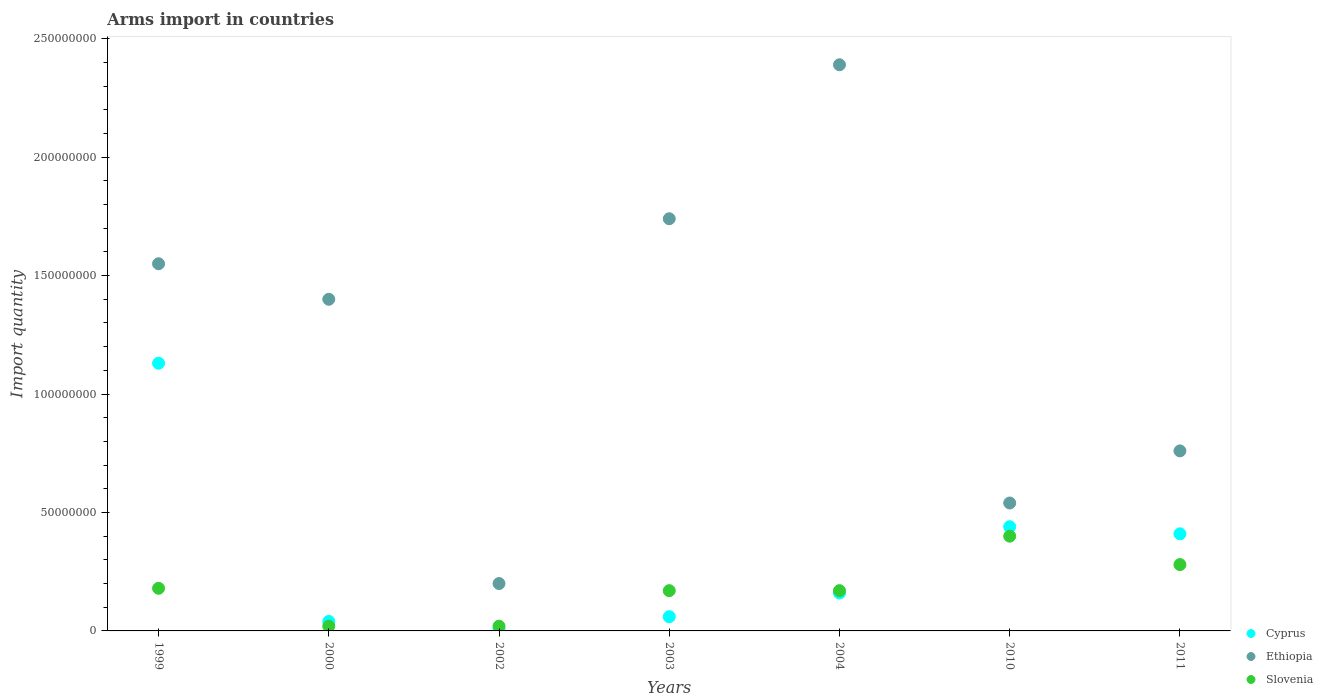What is the total arms import in Ethiopia in 2000?
Your answer should be compact. 1.40e+08. Across all years, what is the maximum total arms import in Cyprus?
Keep it short and to the point. 1.13e+08. Across all years, what is the minimum total arms import in Ethiopia?
Offer a terse response. 2.00e+07. What is the total total arms import in Slovenia in the graph?
Ensure brevity in your answer.  1.24e+08. What is the difference between the total arms import in Slovenia in 1999 and that in 2010?
Offer a terse response. -2.20e+07. What is the difference between the total arms import in Cyprus in 2003 and the total arms import in Slovenia in 1999?
Your response must be concise. -1.20e+07. What is the average total arms import in Ethiopia per year?
Ensure brevity in your answer.  1.23e+08. In how many years, is the total arms import in Cyprus greater than 110000000?
Keep it short and to the point. 1. What is the ratio of the total arms import in Ethiopia in 1999 to that in 2002?
Ensure brevity in your answer.  7.75. Is the difference between the total arms import in Slovenia in 1999 and 2004 greater than the difference between the total arms import in Cyprus in 1999 and 2004?
Make the answer very short. No. What is the difference between the highest and the second highest total arms import in Ethiopia?
Keep it short and to the point. 6.50e+07. What is the difference between the highest and the lowest total arms import in Cyprus?
Keep it short and to the point. 1.12e+08. In how many years, is the total arms import in Slovenia greater than the average total arms import in Slovenia taken over all years?
Give a very brief answer. 3. Is the sum of the total arms import in Ethiopia in 2002 and 2004 greater than the maximum total arms import in Slovenia across all years?
Your response must be concise. Yes. Is it the case that in every year, the sum of the total arms import in Slovenia and total arms import in Cyprus  is greater than the total arms import in Ethiopia?
Make the answer very short. No. Does the total arms import in Slovenia monotonically increase over the years?
Make the answer very short. No. Is the total arms import in Ethiopia strictly greater than the total arms import in Cyprus over the years?
Provide a succinct answer. Yes. How many years are there in the graph?
Your response must be concise. 7. Are the values on the major ticks of Y-axis written in scientific E-notation?
Give a very brief answer. No. Does the graph contain any zero values?
Provide a short and direct response. No. Where does the legend appear in the graph?
Your answer should be compact. Bottom right. What is the title of the graph?
Your answer should be very brief. Arms import in countries. What is the label or title of the Y-axis?
Keep it short and to the point. Import quantity. What is the Import quantity in Cyprus in 1999?
Make the answer very short. 1.13e+08. What is the Import quantity of Ethiopia in 1999?
Provide a short and direct response. 1.55e+08. What is the Import quantity of Slovenia in 1999?
Your answer should be compact. 1.80e+07. What is the Import quantity in Cyprus in 2000?
Give a very brief answer. 4.00e+06. What is the Import quantity of Ethiopia in 2000?
Provide a succinct answer. 1.40e+08. What is the Import quantity in Slovenia in 2000?
Give a very brief answer. 2.00e+06. What is the Import quantity of Cyprus in 2002?
Offer a very short reply. 1.00e+06. What is the Import quantity in Ethiopia in 2002?
Give a very brief answer. 2.00e+07. What is the Import quantity in Slovenia in 2002?
Give a very brief answer. 2.00e+06. What is the Import quantity of Ethiopia in 2003?
Provide a succinct answer. 1.74e+08. What is the Import quantity in Slovenia in 2003?
Ensure brevity in your answer.  1.70e+07. What is the Import quantity in Cyprus in 2004?
Your answer should be very brief. 1.60e+07. What is the Import quantity in Ethiopia in 2004?
Your answer should be compact. 2.39e+08. What is the Import quantity in Slovenia in 2004?
Your answer should be very brief. 1.70e+07. What is the Import quantity in Cyprus in 2010?
Offer a terse response. 4.40e+07. What is the Import quantity in Ethiopia in 2010?
Provide a succinct answer. 5.40e+07. What is the Import quantity in Slovenia in 2010?
Offer a very short reply. 4.00e+07. What is the Import quantity of Cyprus in 2011?
Offer a terse response. 4.10e+07. What is the Import quantity in Ethiopia in 2011?
Your response must be concise. 7.60e+07. What is the Import quantity of Slovenia in 2011?
Provide a short and direct response. 2.80e+07. Across all years, what is the maximum Import quantity of Cyprus?
Give a very brief answer. 1.13e+08. Across all years, what is the maximum Import quantity in Ethiopia?
Make the answer very short. 2.39e+08. Across all years, what is the maximum Import quantity in Slovenia?
Your answer should be very brief. 4.00e+07. Across all years, what is the minimum Import quantity of Cyprus?
Ensure brevity in your answer.  1.00e+06. Across all years, what is the minimum Import quantity of Ethiopia?
Keep it short and to the point. 2.00e+07. What is the total Import quantity of Cyprus in the graph?
Ensure brevity in your answer.  2.25e+08. What is the total Import quantity in Ethiopia in the graph?
Offer a very short reply. 8.58e+08. What is the total Import quantity in Slovenia in the graph?
Give a very brief answer. 1.24e+08. What is the difference between the Import quantity of Cyprus in 1999 and that in 2000?
Your answer should be very brief. 1.09e+08. What is the difference between the Import quantity in Ethiopia in 1999 and that in 2000?
Your answer should be compact. 1.50e+07. What is the difference between the Import quantity of Slovenia in 1999 and that in 2000?
Make the answer very short. 1.60e+07. What is the difference between the Import quantity in Cyprus in 1999 and that in 2002?
Your answer should be compact. 1.12e+08. What is the difference between the Import quantity in Ethiopia in 1999 and that in 2002?
Offer a very short reply. 1.35e+08. What is the difference between the Import quantity in Slovenia in 1999 and that in 2002?
Provide a short and direct response. 1.60e+07. What is the difference between the Import quantity of Cyprus in 1999 and that in 2003?
Provide a short and direct response. 1.07e+08. What is the difference between the Import quantity of Ethiopia in 1999 and that in 2003?
Make the answer very short. -1.90e+07. What is the difference between the Import quantity in Slovenia in 1999 and that in 2003?
Provide a short and direct response. 1.00e+06. What is the difference between the Import quantity in Cyprus in 1999 and that in 2004?
Keep it short and to the point. 9.70e+07. What is the difference between the Import quantity in Ethiopia in 1999 and that in 2004?
Offer a very short reply. -8.40e+07. What is the difference between the Import quantity of Slovenia in 1999 and that in 2004?
Provide a succinct answer. 1.00e+06. What is the difference between the Import quantity in Cyprus in 1999 and that in 2010?
Keep it short and to the point. 6.90e+07. What is the difference between the Import quantity in Ethiopia in 1999 and that in 2010?
Provide a succinct answer. 1.01e+08. What is the difference between the Import quantity of Slovenia in 1999 and that in 2010?
Your answer should be compact. -2.20e+07. What is the difference between the Import quantity in Cyprus in 1999 and that in 2011?
Provide a short and direct response. 7.20e+07. What is the difference between the Import quantity in Ethiopia in 1999 and that in 2011?
Provide a succinct answer. 7.90e+07. What is the difference between the Import quantity of Slovenia in 1999 and that in 2011?
Provide a short and direct response. -1.00e+07. What is the difference between the Import quantity of Cyprus in 2000 and that in 2002?
Make the answer very short. 3.00e+06. What is the difference between the Import quantity of Ethiopia in 2000 and that in 2002?
Offer a terse response. 1.20e+08. What is the difference between the Import quantity in Slovenia in 2000 and that in 2002?
Make the answer very short. 0. What is the difference between the Import quantity in Ethiopia in 2000 and that in 2003?
Provide a short and direct response. -3.40e+07. What is the difference between the Import quantity in Slovenia in 2000 and that in 2003?
Offer a terse response. -1.50e+07. What is the difference between the Import quantity in Cyprus in 2000 and that in 2004?
Provide a succinct answer. -1.20e+07. What is the difference between the Import quantity in Ethiopia in 2000 and that in 2004?
Provide a succinct answer. -9.90e+07. What is the difference between the Import quantity in Slovenia in 2000 and that in 2004?
Keep it short and to the point. -1.50e+07. What is the difference between the Import quantity of Cyprus in 2000 and that in 2010?
Your answer should be very brief. -4.00e+07. What is the difference between the Import quantity of Ethiopia in 2000 and that in 2010?
Offer a very short reply. 8.60e+07. What is the difference between the Import quantity in Slovenia in 2000 and that in 2010?
Give a very brief answer. -3.80e+07. What is the difference between the Import quantity in Cyprus in 2000 and that in 2011?
Ensure brevity in your answer.  -3.70e+07. What is the difference between the Import quantity in Ethiopia in 2000 and that in 2011?
Your answer should be very brief. 6.40e+07. What is the difference between the Import quantity of Slovenia in 2000 and that in 2011?
Ensure brevity in your answer.  -2.60e+07. What is the difference between the Import quantity of Cyprus in 2002 and that in 2003?
Offer a very short reply. -5.00e+06. What is the difference between the Import quantity in Ethiopia in 2002 and that in 2003?
Ensure brevity in your answer.  -1.54e+08. What is the difference between the Import quantity of Slovenia in 2002 and that in 2003?
Provide a short and direct response. -1.50e+07. What is the difference between the Import quantity in Cyprus in 2002 and that in 2004?
Give a very brief answer. -1.50e+07. What is the difference between the Import quantity in Ethiopia in 2002 and that in 2004?
Give a very brief answer. -2.19e+08. What is the difference between the Import quantity in Slovenia in 2002 and that in 2004?
Your response must be concise. -1.50e+07. What is the difference between the Import quantity in Cyprus in 2002 and that in 2010?
Give a very brief answer. -4.30e+07. What is the difference between the Import quantity of Ethiopia in 2002 and that in 2010?
Provide a succinct answer. -3.40e+07. What is the difference between the Import quantity of Slovenia in 2002 and that in 2010?
Make the answer very short. -3.80e+07. What is the difference between the Import quantity in Cyprus in 2002 and that in 2011?
Ensure brevity in your answer.  -4.00e+07. What is the difference between the Import quantity in Ethiopia in 2002 and that in 2011?
Your response must be concise. -5.60e+07. What is the difference between the Import quantity in Slovenia in 2002 and that in 2011?
Your answer should be very brief. -2.60e+07. What is the difference between the Import quantity in Cyprus in 2003 and that in 2004?
Keep it short and to the point. -1.00e+07. What is the difference between the Import quantity in Ethiopia in 2003 and that in 2004?
Keep it short and to the point. -6.50e+07. What is the difference between the Import quantity of Slovenia in 2003 and that in 2004?
Ensure brevity in your answer.  0. What is the difference between the Import quantity of Cyprus in 2003 and that in 2010?
Offer a terse response. -3.80e+07. What is the difference between the Import quantity in Ethiopia in 2003 and that in 2010?
Offer a terse response. 1.20e+08. What is the difference between the Import quantity of Slovenia in 2003 and that in 2010?
Your answer should be very brief. -2.30e+07. What is the difference between the Import quantity of Cyprus in 2003 and that in 2011?
Provide a succinct answer. -3.50e+07. What is the difference between the Import quantity of Ethiopia in 2003 and that in 2011?
Offer a very short reply. 9.80e+07. What is the difference between the Import quantity of Slovenia in 2003 and that in 2011?
Provide a short and direct response. -1.10e+07. What is the difference between the Import quantity of Cyprus in 2004 and that in 2010?
Provide a succinct answer. -2.80e+07. What is the difference between the Import quantity of Ethiopia in 2004 and that in 2010?
Offer a terse response. 1.85e+08. What is the difference between the Import quantity of Slovenia in 2004 and that in 2010?
Offer a terse response. -2.30e+07. What is the difference between the Import quantity in Cyprus in 2004 and that in 2011?
Offer a terse response. -2.50e+07. What is the difference between the Import quantity of Ethiopia in 2004 and that in 2011?
Give a very brief answer. 1.63e+08. What is the difference between the Import quantity of Slovenia in 2004 and that in 2011?
Offer a terse response. -1.10e+07. What is the difference between the Import quantity in Cyprus in 2010 and that in 2011?
Provide a succinct answer. 3.00e+06. What is the difference between the Import quantity of Ethiopia in 2010 and that in 2011?
Provide a succinct answer. -2.20e+07. What is the difference between the Import quantity of Slovenia in 2010 and that in 2011?
Your answer should be very brief. 1.20e+07. What is the difference between the Import quantity of Cyprus in 1999 and the Import quantity of Ethiopia in 2000?
Ensure brevity in your answer.  -2.70e+07. What is the difference between the Import quantity of Cyprus in 1999 and the Import quantity of Slovenia in 2000?
Provide a short and direct response. 1.11e+08. What is the difference between the Import quantity in Ethiopia in 1999 and the Import quantity in Slovenia in 2000?
Make the answer very short. 1.53e+08. What is the difference between the Import quantity of Cyprus in 1999 and the Import quantity of Ethiopia in 2002?
Provide a succinct answer. 9.30e+07. What is the difference between the Import quantity of Cyprus in 1999 and the Import quantity of Slovenia in 2002?
Your answer should be very brief. 1.11e+08. What is the difference between the Import quantity in Ethiopia in 1999 and the Import quantity in Slovenia in 2002?
Give a very brief answer. 1.53e+08. What is the difference between the Import quantity in Cyprus in 1999 and the Import quantity in Ethiopia in 2003?
Provide a succinct answer. -6.10e+07. What is the difference between the Import quantity in Cyprus in 1999 and the Import quantity in Slovenia in 2003?
Ensure brevity in your answer.  9.60e+07. What is the difference between the Import quantity of Ethiopia in 1999 and the Import quantity of Slovenia in 2003?
Make the answer very short. 1.38e+08. What is the difference between the Import quantity of Cyprus in 1999 and the Import quantity of Ethiopia in 2004?
Your answer should be very brief. -1.26e+08. What is the difference between the Import quantity in Cyprus in 1999 and the Import quantity in Slovenia in 2004?
Your answer should be very brief. 9.60e+07. What is the difference between the Import quantity of Ethiopia in 1999 and the Import quantity of Slovenia in 2004?
Offer a very short reply. 1.38e+08. What is the difference between the Import quantity in Cyprus in 1999 and the Import quantity in Ethiopia in 2010?
Offer a very short reply. 5.90e+07. What is the difference between the Import quantity of Cyprus in 1999 and the Import quantity of Slovenia in 2010?
Make the answer very short. 7.30e+07. What is the difference between the Import quantity of Ethiopia in 1999 and the Import quantity of Slovenia in 2010?
Ensure brevity in your answer.  1.15e+08. What is the difference between the Import quantity in Cyprus in 1999 and the Import quantity in Ethiopia in 2011?
Provide a succinct answer. 3.70e+07. What is the difference between the Import quantity in Cyprus in 1999 and the Import quantity in Slovenia in 2011?
Ensure brevity in your answer.  8.50e+07. What is the difference between the Import quantity in Ethiopia in 1999 and the Import quantity in Slovenia in 2011?
Your answer should be very brief. 1.27e+08. What is the difference between the Import quantity in Cyprus in 2000 and the Import quantity in Ethiopia in 2002?
Make the answer very short. -1.60e+07. What is the difference between the Import quantity of Cyprus in 2000 and the Import quantity of Slovenia in 2002?
Make the answer very short. 2.00e+06. What is the difference between the Import quantity in Ethiopia in 2000 and the Import quantity in Slovenia in 2002?
Make the answer very short. 1.38e+08. What is the difference between the Import quantity in Cyprus in 2000 and the Import quantity in Ethiopia in 2003?
Offer a terse response. -1.70e+08. What is the difference between the Import quantity of Cyprus in 2000 and the Import quantity of Slovenia in 2003?
Provide a short and direct response. -1.30e+07. What is the difference between the Import quantity in Ethiopia in 2000 and the Import quantity in Slovenia in 2003?
Ensure brevity in your answer.  1.23e+08. What is the difference between the Import quantity in Cyprus in 2000 and the Import quantity in Ethiopia in 2004?
Keep it short and to the point. -2.35e+08. What is the difference between the Import quantity in Cyprus in 2000 and the Import quantity in Slovenia in 2004?
Offer a terse response. -1.30e+07. What is the difference between the Import quantity in Ethiopia in 2000 and the Import quantity in Slovenia in 2004?
Provide a succinct answer. 1.23e+08. What is the difference between the Import quantity in Cyprus in 2000 and the Import quantity in Ethiopia in 2010?
Make the answer very short. -5.00e+07. What is the difference between the Import quantity in Cyprus in 2000 and the Import quantity in Slovenia in 2010?
Ensure brevity in your answer.  -3.60e+07. What is the difference between the Import quantity in Cyprus in 2000 and the Import quantity in Ethiopia in 2011?
Your answer should be very brief. -7.20e+07. What is the difference between the Import quantity in Cyprus in 2000 and the Import quantity in Slovenia in 2011?
Ensure brevity in your answer.  -2.40e+07. What is the difference between the Import quantity in Ethiopia in 2000 and the Import quantity in Slovenia in 2011?
Your answer should be very brief. 1.12e+08. What is the difference between the Import quantity in Cyprus in 2002 and the Import quantity in Ethiopia in 2003?
Your answer should be very brief. -1.73e+08. What is the difference between the Import quantity of Cyprus in 2002 and the Import quantity of Slovenia in 2003?
Provide a succinct answer. -1.60e+07. What is the difference between the Import quantity in Cyprus in 2002 and the Import quantity in Ethiopia in 2004?
Your answer should be compact. -2.38e+08. What is the difference between the Import quantity in Cyprus in 2002 and the Import quantity in Slovenia in 2004?
Provide a succinct answer. -1.60e+07. What is the difference between the Import quantity in Ethiopia in 2002 and the Import quantity in Slovenia in 2004?
Ensure brevity in your answer.  3.00e+06. What is the difference between the Import quantity of Cyprus in 2002 and the Import quantity of Ethiopia in 2010?
Your answer should be compact. -5.30e+07. What is the difference between the Import quantity in Cyprus in 2002 and the Import quantity in Slovenia in 2010?
Provide a succinct answer. -3.90e+07. What is the difference between the Import quantity of Ethiopia in 2002 and the Import quantity of Slovenia in 2010?
Give a very brief answer. -2.00e+07. What is the difference between the Import quantity of Cyprus in 2002 and the Import quantity of Ethiopia in 2011?
Ensure brevity in your answer.  -7.50e+07. What is the difference between the Import quantity of Cyprus in 2002 and the Import quantity of Slovenia in 2011?
Your response must be concise. -2.70e+07. What is the difference between the Import quantity in Ethiopia in 2002 and the Import quantity in Slovenia in 2011?
Offer a terse response. -8.00e+06. What is the difference between the Import quantity in Cyprus in 2003 and the Import quantity in Ethiopia in 2004?
Your answer should be compact. -2.33e+08. What is the difference between the Import quantity in Cyprus in 2003 and the Import quantity in Slovenia in 2004?
Your answer should be very brief. -1.10e+07. What is the difference between the Import quantity in Ethiopia in 2003 and the Import quantity in Slovenia in 2004?
Provide a short and direct response. 1.57e+08. What is the difference between the Import quantity of Cyprus in 2003 and the Import quantity of Ethiopia in 2010?
Offer a terse response. -4.80e+07. What is the difference between the Import quantity of Cyprus in 2003 and the Import quantity of Slovenia in 2010?
Offer a terse response. -3.40e+07. What is the difference between the Import quantity of Ethiopia in 2003 and the Import quantity of Slovenia in 2010?
Give a very brief answer. 1.34e+08. What is the difference between the Import quantity of Cyprus in 2003 and the Import quantity of Ethiopia in 2011?
Give a very brief answer. -7.00e+07. What is the difference between the Import quantity in Cyprus in 2003 and the Import quantity in Slovenia in 2011?
Your response must be concise. -2.20e+07. What is the difference between the Import quantity of Ethiopia in 2003 and the Import quantity of Slovenia in 2011?
Ensure brevity in your answer.  1.46e+08. What is the difference between the Import quantity in Cyprus in 2004 and the Import quantity in Ethiopia in 2010?
Keep it short and to the point. -3.80e+07. What is the difference between the Import quantity in Cyprus in 2004 and the Import quantity in Slovenia in 2010?
Ensure brevity in your answer.  -2.40e+07. What is the difference between the Import quantity of Ethiopia in 2004 and the Import quantity of Slovenia in 2010?
Provide a succinct answer. 1.99e+08. What is the difference between the Import quantity of Cyprus in 2004 and the Import quantity of Ethiopia in 2011?
Offer a terse response. -6.00e+07. What is the difference between the Import quantity in Cyprus in 2004 and the Import quantity in Slovenia in 2011?
Your response must be concise. -1.20e+07. What is the difference between the Import quantity of Ethiopia in 2004 and the Import quantity of Slovenia in 2011?
Provide a short and direct response. 2.11e+08. What is the difference between the Import quantity in Cyprus in 2010 and the Import quantity in Ethiopia in 2011?
Keep it short and to the point. -3.20e+07. What is the difference between the Import quantity of Cyprus in 2010 and the Import quantity of Slovenia in 2011?
Offer a terse response. 1.60e+07. What is the difference between the Import quantity of Ethiopia in 2010 and the Import quantity of Slovenia in 2011?
Keep it short and to the point. 2.60e+07. What is the average Import quantity of Cyprus per year?
Keep it short and to the point. 3.21e+07. What is the average Import quantity of Ethiopia per year?
Give a very brief answer. 1.23e+08. What is the average Import quantity in Slovenia per year?
Provide a short and direct response. 1.77e+07. In the year 1999, what is the difference between the Import quantity in Cyprus and Import quantity in Ethiopia?
Make the answer very short. -4.20e+07. In the year 1999, what is the difference between the Import quantity in Cyprus and Import quantity in Slovenia?
Keep it short and to the point. 9.50e+07. In the year 1999, what is the difference between the Import quantity in Ethiopia and Import quantity in Slovenia?
Provide a succinct answer. 1.37e+08. In the year 2000, what is the difference between the Import quantity in Cyprus and Import quantity in Ethiopia?
Your answer should be compact. -1.36e+08. In the year 2000, what is the difference between the Import quantity of Cyprus and Import quantity of Slovenia?
Your answer should be compact. 2.00e+06. In the year 2000, what is the difference between the Import quantity of Ethiopia and Import quantity of Slovenia?
Make the answer very short. 1.38e+08. In the year 2002, what is the difference between the Import quantity in Cyprus and Import quantity in Ethiopia?
Offer a very short reply. -1.90e+07. In the year 2002, what is the difference between the Import quantity in Ethiopia and Import quantity in Slovenia?
Provide a short and direct response. 1.80e+07. In the year 2003, what is the difference between the Import quantity of Cyprus and Import quantity of Ethiopia?
Your answer should be very brief. -1.68e+08. In the year 2003, what is the difference between the Import quantity of Cyprus and Import quantity of Slovenia?
Offer a terse response. -1.10e+07. In the year 2003, what is the difference between the Import quantity of Ethiopia and Import quantity of Slovenia?
Provide a succinct answer. 1.57e+08. In the year 2004, what is the difference between the Import quantity in Cyprus and Import quantity in Ethiopia?
Your answer should be very brief. -2.23e+08. In the year 2004, what is the difference between the Import quantity in Ethiopia and Import quantity in Slovenia?
Provide a short and direct response. 2.22e+08. In the year 2010, what is the difference between the Import quantity in Cyprus and Import quantity in Ethiopia?
Your response must be concise. -1.00e+07. In the year 2010, what is the difference between the Import quantity of Ethiopia and Import quantity of Slovenia?
Keep it short and to the point. 1.40e+07. In the year 2011, what is the difference between the Import quantity in Cyprus and Import quantity in Ethiopia?
Provide a short and direct response. -3.50e+07. In the year 2011, what is the difference between the Import quantity of Cyprus and Import quantity of Slovenia?
Your response must be concise. 1.30e+07. In the year 2011, what is the difference between the Import quantity of Ethiopia and Import quantity of Slovenia?
Your answer should be very brief. 4.80e+07. What is the ratio of the Import quantity of Cyprus in 1999 to that in 2000?
Your answer should be very brief. 28.25. What is the ratio of the Import quantity of Ethiopia in 1999 to that in 2000?
Give a very brief answer. 1.11. What is the ratio of the Import quantity in Slovenia in 1999 to that in 2000?
Ensure brevity in your answer.  9. What is the ratio of the Import quantity in Cyprus in 1999 to that in 2002?
Keep it short and to the point. 113. What is the ratio of the Import quantity in Ethiopia in 1999 to that in 2002?
Provide a short and direct response. 7.75. What is the ratio of the Import quantity in Slovenia in 1999 to that in 2002?
Offer a very short reply. 9. What is the ratio of the Import quantity of Cyprus in 1999 to that in 2003?
Keep it short and to the point. 18.83. What is the ratio of the Import quantity in Ethiopia in 1999 to that in 2003?
Make the answer very short. 0.89. What is the ratio of the Import quantity in Slovenia in 1999 to that in 2003?
Offer a terse response. 1.06. What is the ratio of the Import quantity of Cyprus in 1999 to that in 2004?
Provide a succinct answer. 7.06. What is the ratio of the Import quantity of Ethiopia in 1999 to that in 2004?
Keep it short and to the point. 0.65. What is the ratio of the Import quantity of Slovenia in 1999 to that in 2004?
Offer a very short reply. 1.06. What is the ratio of the Import quantity of Cyprus in 1999 to that in 2010?
Your response must be concise. 2.57. What is the ratio of the Import quantity of Ethiopia in 1999 to that in 2010?
Ensure brevity in your answer.  2.87. What is the ratio of the Import quantity in Slovenia in 1999 to that in 2010?
Ensure brevity in your answer.  0.45. What is the ratio of the Import quantity of Cyprus in 1999 to that in 2011?
Ensure brevity in your answer.  2.76. What is the ratio of the Import quantity of Ethiopia in 1999 to that in 2011?
Provide a short and direct response. 2.04. What is the ratio of the Import quantity of Slovenia in 1999 to that in 2011?
Provide a short and direct response. 0.64. What is the ratio of the Import quantity of Ethiopia in 2000 to that in 2003?
Give a very brief answer. 0.8. What is the ratio of the Import quantity of Slovenia in 2000 to that in 2003?
Offer a terse response. 0.12. What is the ratio of the Import quantity of Cyprus in 2000 to that in 2004?
Provide a short and direct response. 0.25. What is the ratio of the Import quantity in Ethiopia in 2000 to that in 2004?
Keep it short and to the point. 0.59. What is the ratio of the Import quantity in Slovenia in 2000 to that in 2004?
Give a very brief answer. 0.12. What is the ratio of the Import quantity of Cyprus in 2000 to that in 2010?
Make the answer very short. 0.09. What is the ratio of the Import quantity in Ethiopia in 2000 to that in 2010?
Your response must be concise. 2.59. What is the ratio of the Import quantity in Cyprus in 2000 to that in 2011?
Your response must be concise. 0.1. What is the ratio of the Import quantity in Ethiopia in 2000 to that in 2011?
Make the answer very short. 1.84. What is the ratio of the Import quantity of Slovenia in 2000 to that in 2011?
Make the answer very short. 0.07. What is the ratio of the Import quantity in Cyprus in 2002 to that in 2003?
Make the answer very short. 0.17. What is the ratio of the Import quantity in Ethiopia in 2002 to that in 2003?
Offer a terse response. 0.11. What is the ratio of the Import quantity of Slovenia in 2002 to that in 2003?
Make the answer very short. 0.12. What is the ratio of the Import quantity of Cyprus in 2002 to that in 2004?
Your answer should be compact. 0.06. What is the ratio of the Import quantity in Ethiopia in 2002 to that in 2004?
Your answer should be compact. 0.08. What is the ratio of the Import quantity in Slovenia in 2002 to that in 2004?
Provide a short and direct response. 0.12. What is the ratio of the Import quantity of Cyprus in 2002 to that in 2010?
Give a very brief answer. 0.02. What is the ratio of the Import quantity in Ethiopia in 2002 to that in 2010?
Your answer should be very brief. 0.37. What is the ratio of the Import quantity of Slovenia in 2002 to that in 2010?
Make the answer very short. 0.05. What is the ratio of the Import quantity of Cyprus in 2002 to that in 2011?
Provide a short and direct response. 0.02. What is the ratio of the Import quantity in Ethiopia in 2002 to that in 2011?
Your response must be concise. 0.26. What is the ratio of the Import quantity in Slovenia in 2002 to that in 2011?
Your response must be concise. 0.07. What is the ratio of the Import quantity of Ethiopia in 2003 to that in 2004?
Provide a short and direct response. 0.73. What is the ratio of the Import quantity in Cyprus in 2003 to that in 2010?
Ensure brevity in your answer.  0.14. What is the ratio of the Import quantity in Ethiopia in 2003 to that in 2010?
Offer a terse response. 3.22. What is the ratio of the Import quantity of Slovenia in 2003 to that in 2010?
Give a very brief answer. 0.42. What is the ratio of the Import quantity of Cyprus in 2003 to that in 2011?
Offer a very short reply. 0.15. What is the ratio of the Import quantity in Ethiopia in 2003 to that in 2011?
Your answer should be compact. 2.29. What is the ratio of the Import quantity in Slovenia in 2003 to that in 2011?
Provide a succinct answer. 0.61. What is the ratio of the Import quantity of Cyprus in 2004 to that in 2010?
Make the answer very short. 0.36. What is the ratio of the Import quantity in Ethiopia in 2004 to that in 2010?
Ensure brevity in your answer.  4.43. What is the ratio of the Import quantity in Slovenia in 2004 to that in 2010?
Your answer should be very brief. 0.42. What is the ratio of the Import quantity of Cyprus in 2004 to that in 2011?
Provide a short and direct response. 0.39. What is the ratio of the Import quantity in Ethiopia in 2004 to that in 2011?
Keep it short and to the point. 3.14. What is the ratio of the Import quantity of Slovenia in 2004 to that in 2011?
Offer a terse response. 0.61. What is the ratio of the Import quantity of Cyprus in 2010 to that in 2011?
Your response must be concise. 1.07. What is the ratio of the Import quantity of Ethiopia in 2010 to that in 2011?
Provide a succinct answer. 0.71. What is the ratio of the Import quantity in Slovenia in 2010 to that in 2011?
Keep it short and to the point. 1.43. What is the difference between the highest and the second highest Import quantity of Cyprus?
Provide a short and direct response. 6.90e+07. What is the difference between the highest and the second highest Import quantity in Ethiopia?
Your answer should be compact. 6.50e+07. What is the difference between the highest and the second highest Import quantity of Slovenia?
Keep it short and to the point. 1.20e+07. What is the difference between the highest and the lowest Import quantity in Cyprus?
Offer a very short reply. 1.12e+08. What is the difference between the highest and the lowest Import quantity of Ethiopia?
Give a very brief answer. 2.19e+08. What is the difference between the highest and the lowest Import quantity of Slovenia?
Provide a succinct answer. 3.80e+07. 